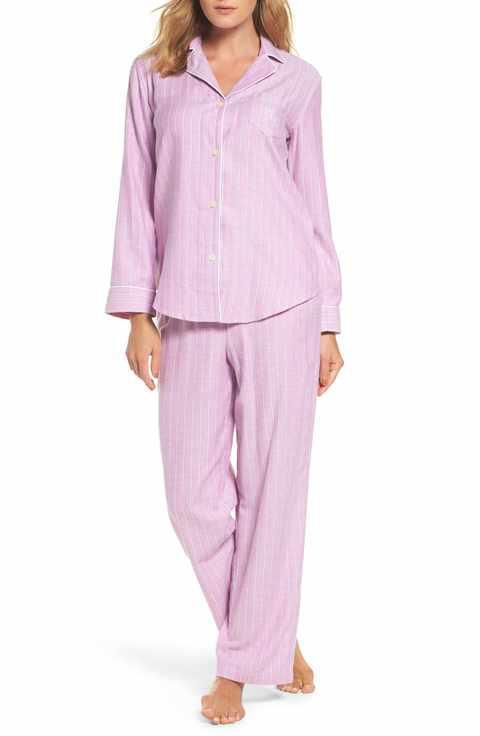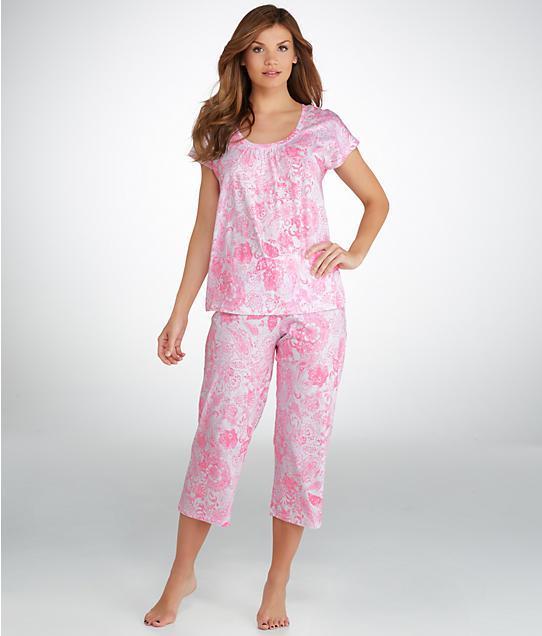The first image is the image on the left, the second image is the image on the right. Analyze the images presented: Is the assertion "A woman is wearing a pajama with short sleeves in one of the images." valid? Answer yes or no. Yes. The first image is the image on the left, the second image is the image on the right. Evaluate the accuracy of this statement regarding the images: "Exactly one model wears a long sleeved collared button-up top, and exactly one model wears a short sleeve top, but no model wears short shorts.". Is it true? Answer yes or no. Yes. 